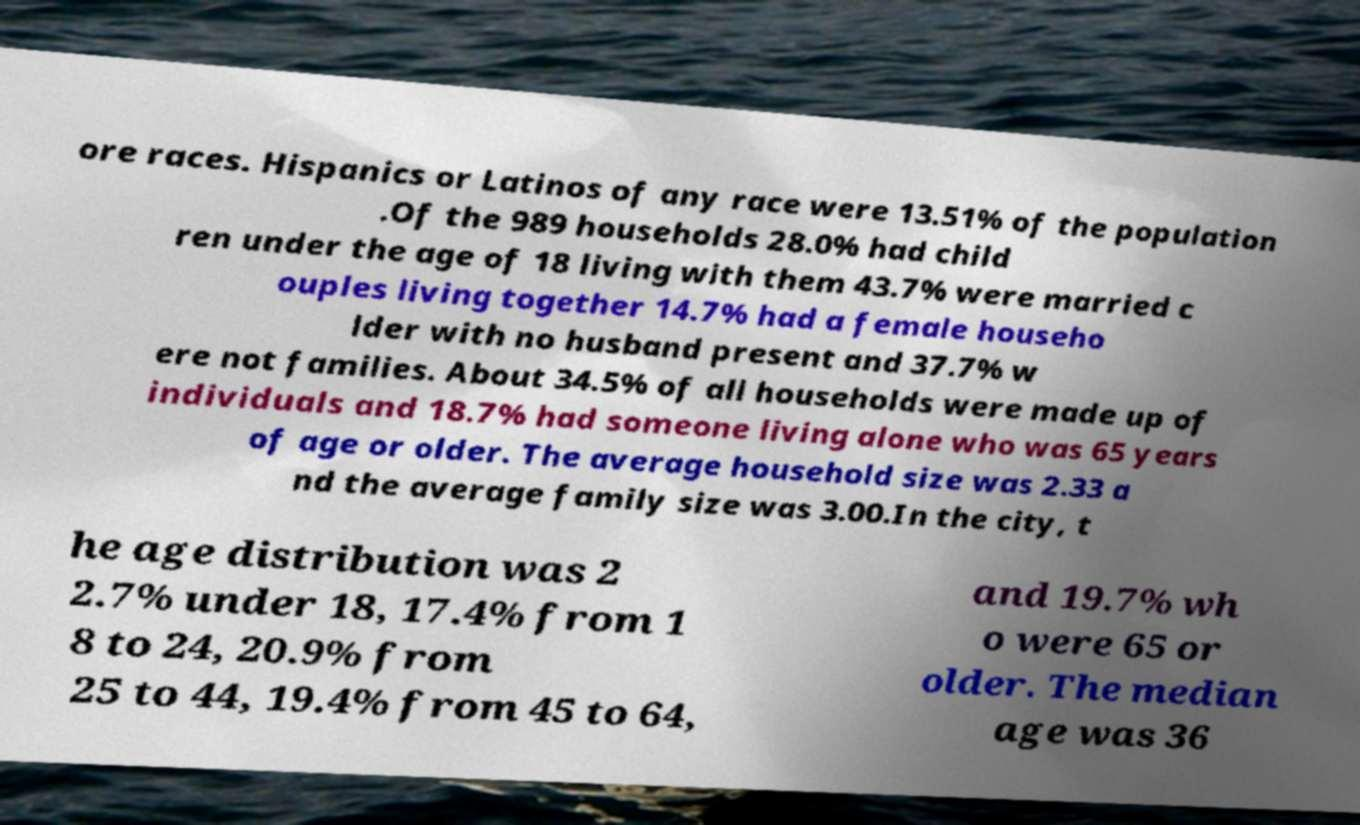Please read and relay the text visible in this image. What does it say? ore races. Hispanics or Latinos of any race were 13.51% of the population .Of the 989 households 28.0% had child ren under the age of 18 living with them 43.7% were married c ouples living together 14.7% had a female househo lder with no husband present and 37.7% w ere not families. About 34.5% of all households were made up of individuals and 18.7% had someone living alone who was 65 years of age or older. The average household size was 2.33 a nd the average family size was 3.00.In the city, t he age distribution was 2 2.7% under 18, 17.4% from 1 8 to 24, 20.9% from 25 to 44, 19.4% from 45 to 64, and 19.7% wh o were 65 or older. The median age was 36 